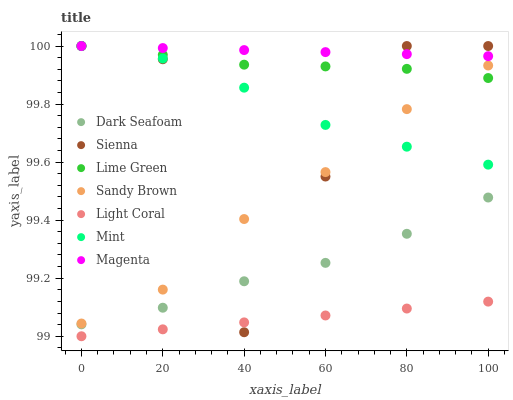Does Light Coral have the minimum area under the curve?
Answer yes or no. Yes. Does Magenta have the maximum area under the curve?
Answer yes or no. Yes. Does Lime Green have the minimum area under the curve?
Answer yes or no. No. Does Lime Green have the maximum area under the curve?
Answer yes or no. No. Is Light Coral the smoothest?
Answer yes or no. Yes. Is Sienna the roughest?
Answer yes or no. Yes. Is Lime Green the smoothest?
Answer yes or no. No. Is Lime Green the roughest?
Answer yes or no. No. Does Light Coral have the lowest value?
Answer yes or no. Yes. Does Lime Green have the lowest value?
Answer yes or no. No. Does Mint have the highest value?
Answer yes or no. Yes. Does Dark Seafoam have the highest value?
Answer yes or no. No. Is Dark Seafoam less than Sandy Brown?
Answer yes or no. Yes. Is Mint greater than Dark Seafoam?
Answer yes or no. Yes. Does Magenta intersect Mint?
Answer yes or no. Yes. Is Magenta less than Mint?
Answer yes or no. No. Is Magenta greater than Mint?
Answer yes or no. No. Does Dark Seafoam intersect Sandy Brown?
Answer yes or no. No. 